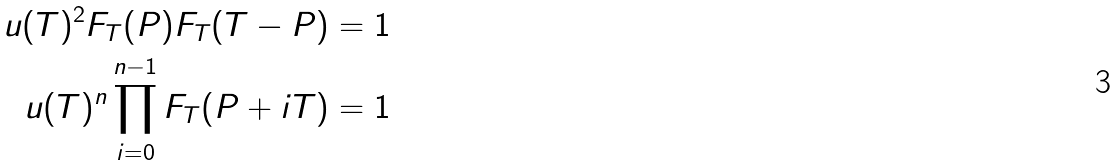Convert formula to latex. <formula><loc_0><loc_0><loc_500><loc_500>u ( T ) ^ { 2 } F _ { T } ( P ) F _ { T } ( T - P ) & = 1 \\ u ( T ) ^ { n } \prod _ { i = 0 } ^ { n - 1 } F _ { T } ( P + i T ) & = 1</formula> 